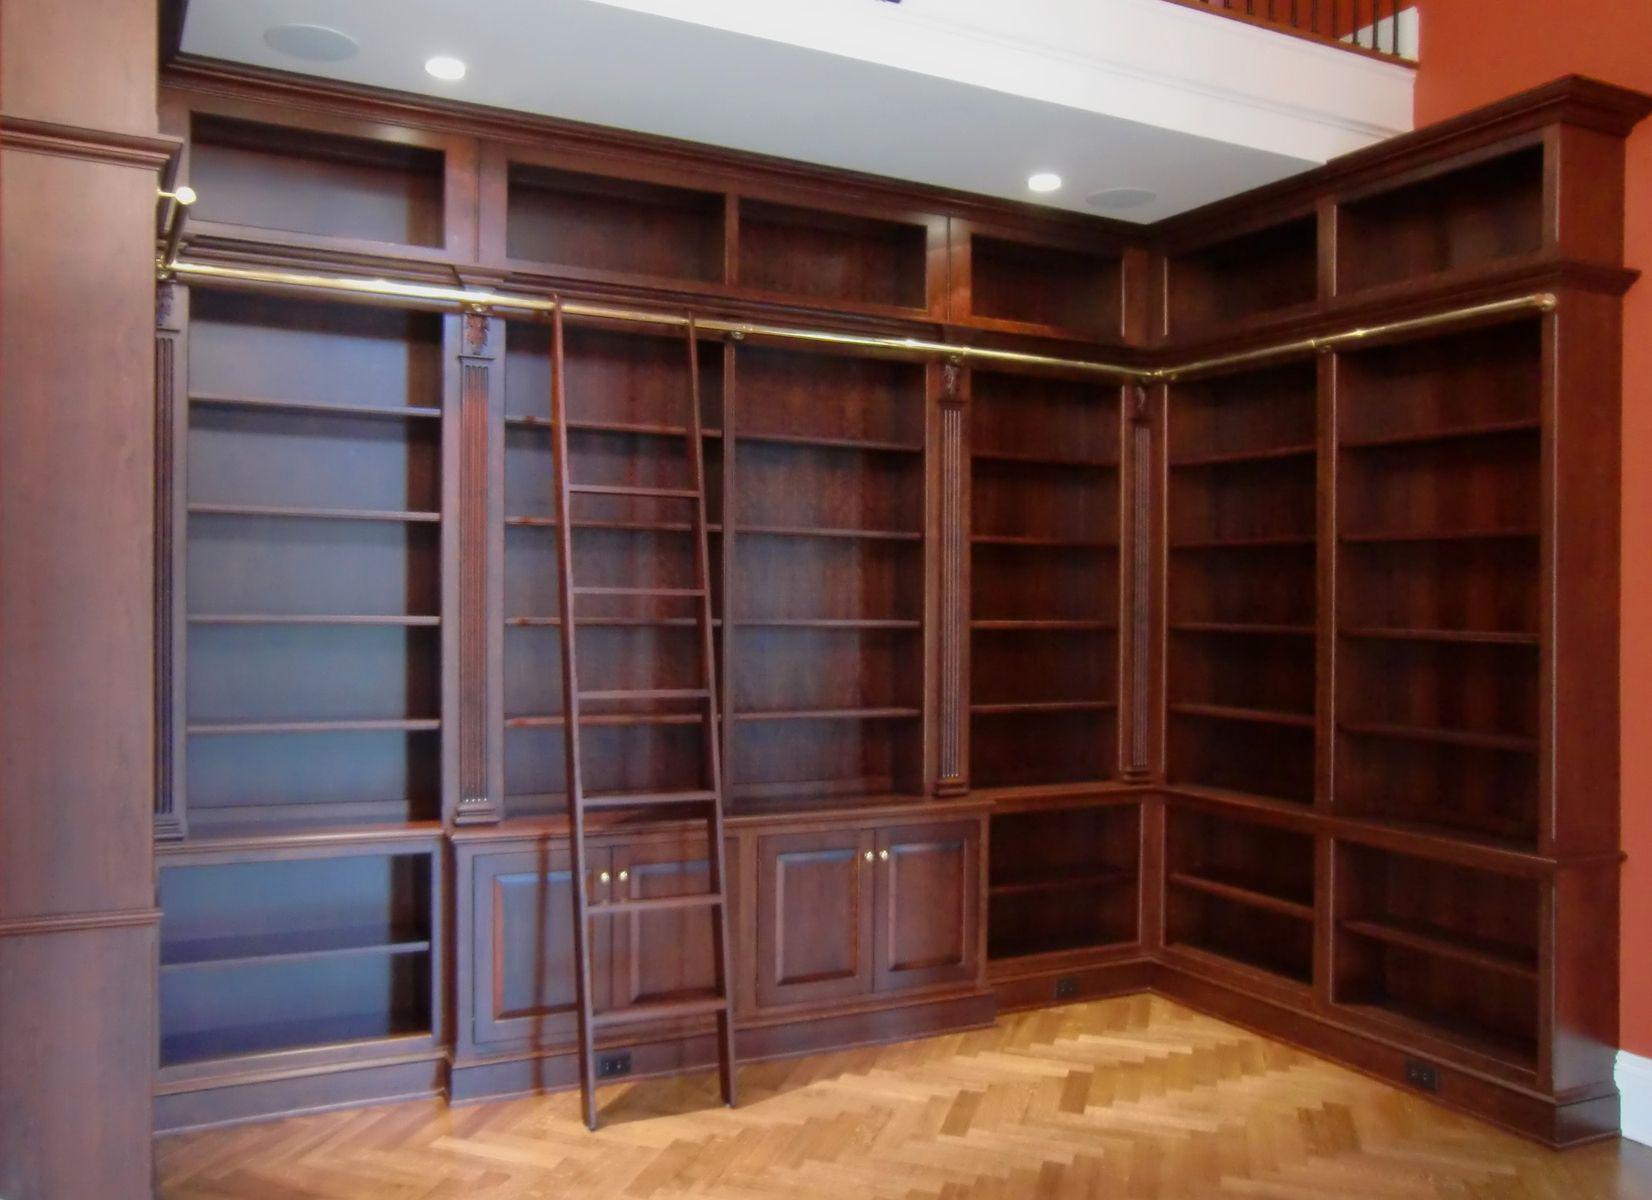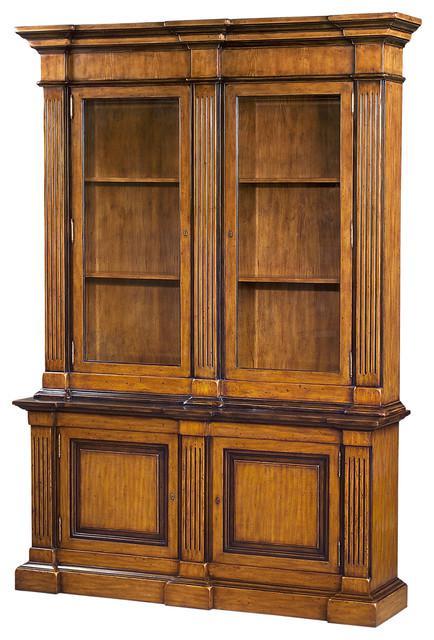The first image is the image on the left, the second image is the image on the right. For the images shown, is this caption "A bookcase in one image has three side-by-side upper shelf units over six solid doors." true? Answer yes or no. No. The first image is the image on the left, the second image is the image on the right. Considering the images on both sides, is "The shelves have no objects resting on them." valid? Answer yes or no. Yes. 